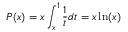Convert formula to latex. <formula><loc_0><loc_0><loc_500><loc_500>P ( x ) = x \int _ { x } ^ { 1 } \frac { 1 } { t } d t = x \ln ( x )</formula> 